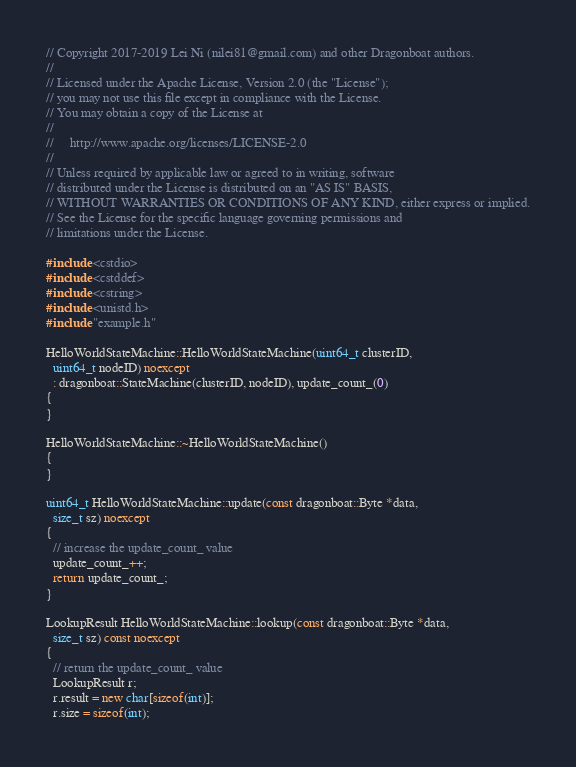<code> <loc_0><loc_0><loc_500><loc_500><_C++_>// Copyright 2017-2019 Lei Ni (nilei81@gmail.com) and other Dragonboat authors.
//
// Licensed under the Apache License, Version 2.0 (the "License");
// you may not use this file except in compliance with the License.
// You may obtain a copy of the License at
//
//     http://www.apache.org/licenses/LICENSE-2.0
//
// Unless required by applicable law or agreed to in writing, software
// distributed under the License is distributed on an "AS IS" BASIS,
// WITHOUT WARRANTIES OR CONDITIONS OF ANY KIND, either express or implied.
// See the License for the specific language governing permissions and
// limitations under the License.

#include <cstdio>
#include <cstddef>
#include <cstring>
#include <unistd.h>
#include "example.h"

HelloWorldStateMachine::HelloWorldStateMachine(uint64_t clusterID,
  uint64_t nodeID) noexcept
  : dragonboat::StateMachine(clusterID, nodeID), update_count_(0)
{
}

HelloWorldStateMachine::~HelloWorldStateMachine()
{
}

uint64_t HelloWorldStateMachine::update(const dragonboat::Byte *data,
  size_t sz) noexcept
{
  // increase the update_count_ value
  update_count_++;
  return update_count_;
}

LookupResult HelloWorldStateMachine::lookup(const dragonboat::Byte *data,
  size_t sz) const noexcept
{
  // return the update_count_ value
  LookupResult r;
  r.result = new char[sizeof(int)];
  r.size = sizeof(int);</code> 